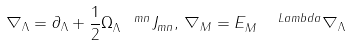Convert formula to latex. <formula><loc_0><loc_0><loc_500><loc_500>\nabla _ { \Lambda } = \partial _ { \Lambda } + \frac { 1 } { 2 } \Omega _ { \Lambda } ^ { \ \ m n } J _ { m n } , \, \nabla _ { M } = E _ { M } ^ { \quad L a m b d a } \nabla _ { \Lambda }</formula> 